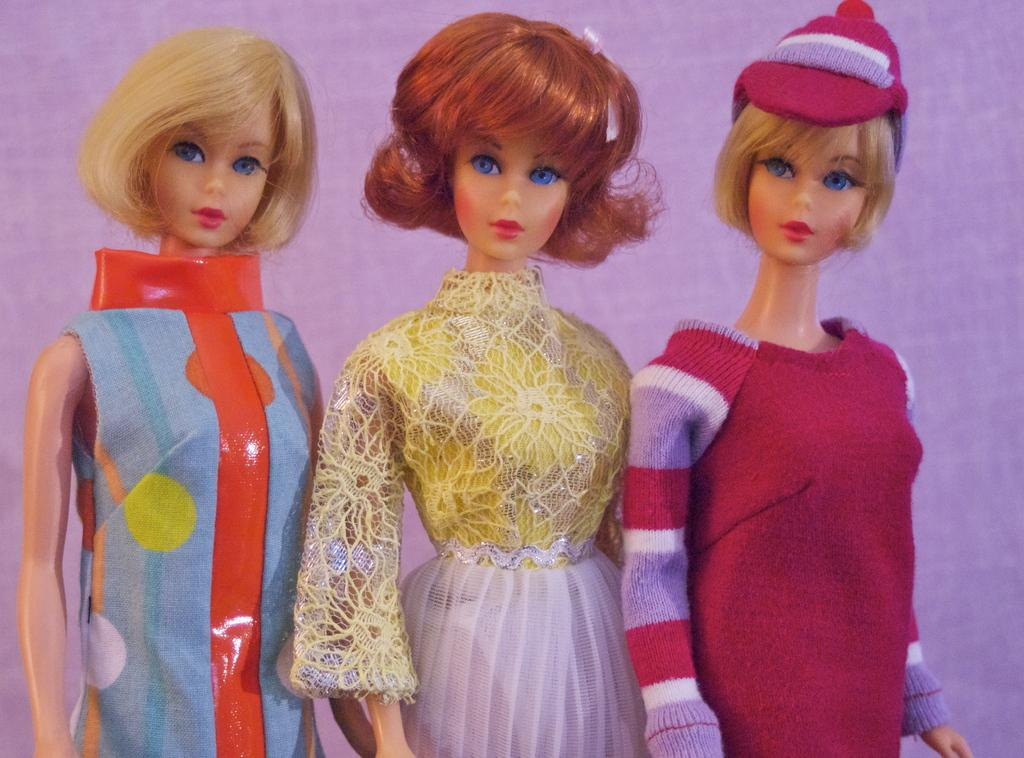How many Barbie dolls are present in the image? There are three Barbie dolls in the image. What can be observed about the appearance of the Barbie dolls? The Barbie dolls are wearing different dresses. What type of instrument is the Barbie doll playing in the image? There is no instrument present in the image, as it only features Barbie dolls wearing different dresses. 